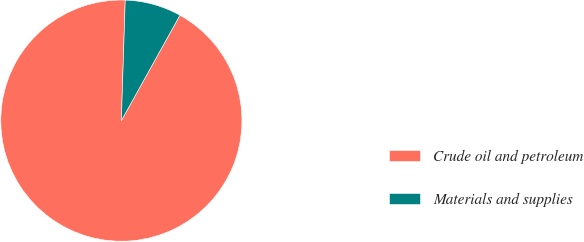<chart> <loc_0><loc_0><loc_500><loc_500><pie_chart><fcel>Crude oil and petroleum<fcel>Materials and supplies<nl><fcel>92.44%<fcel>7.56%<nl></chart> 